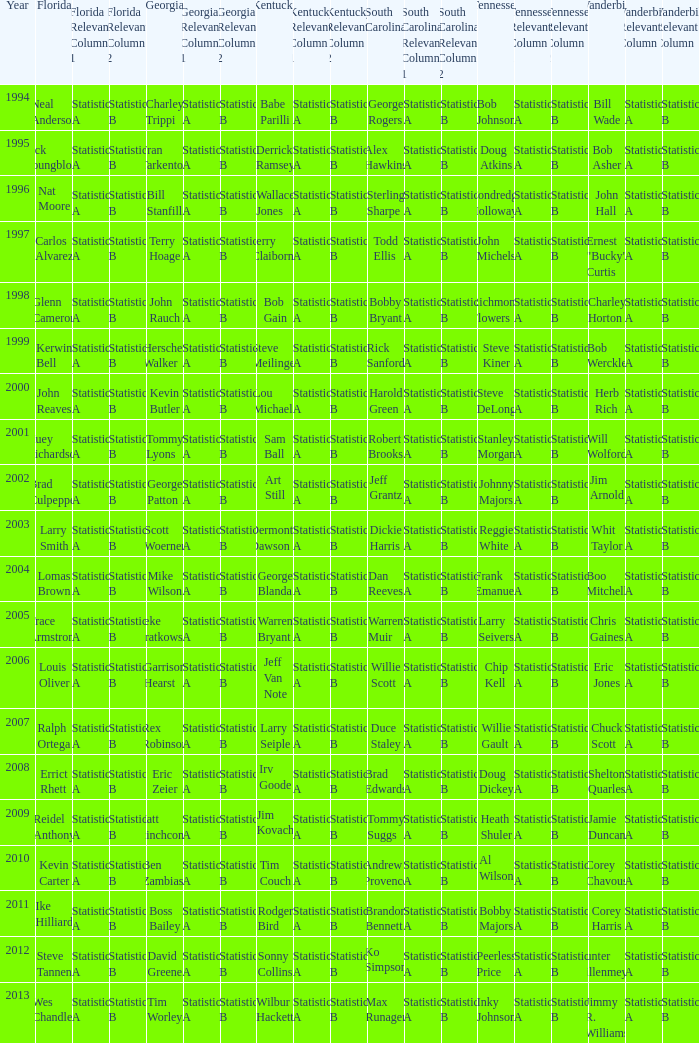What is the Tennessee that Georgia of kevin butler is in? Steve DeLong. 